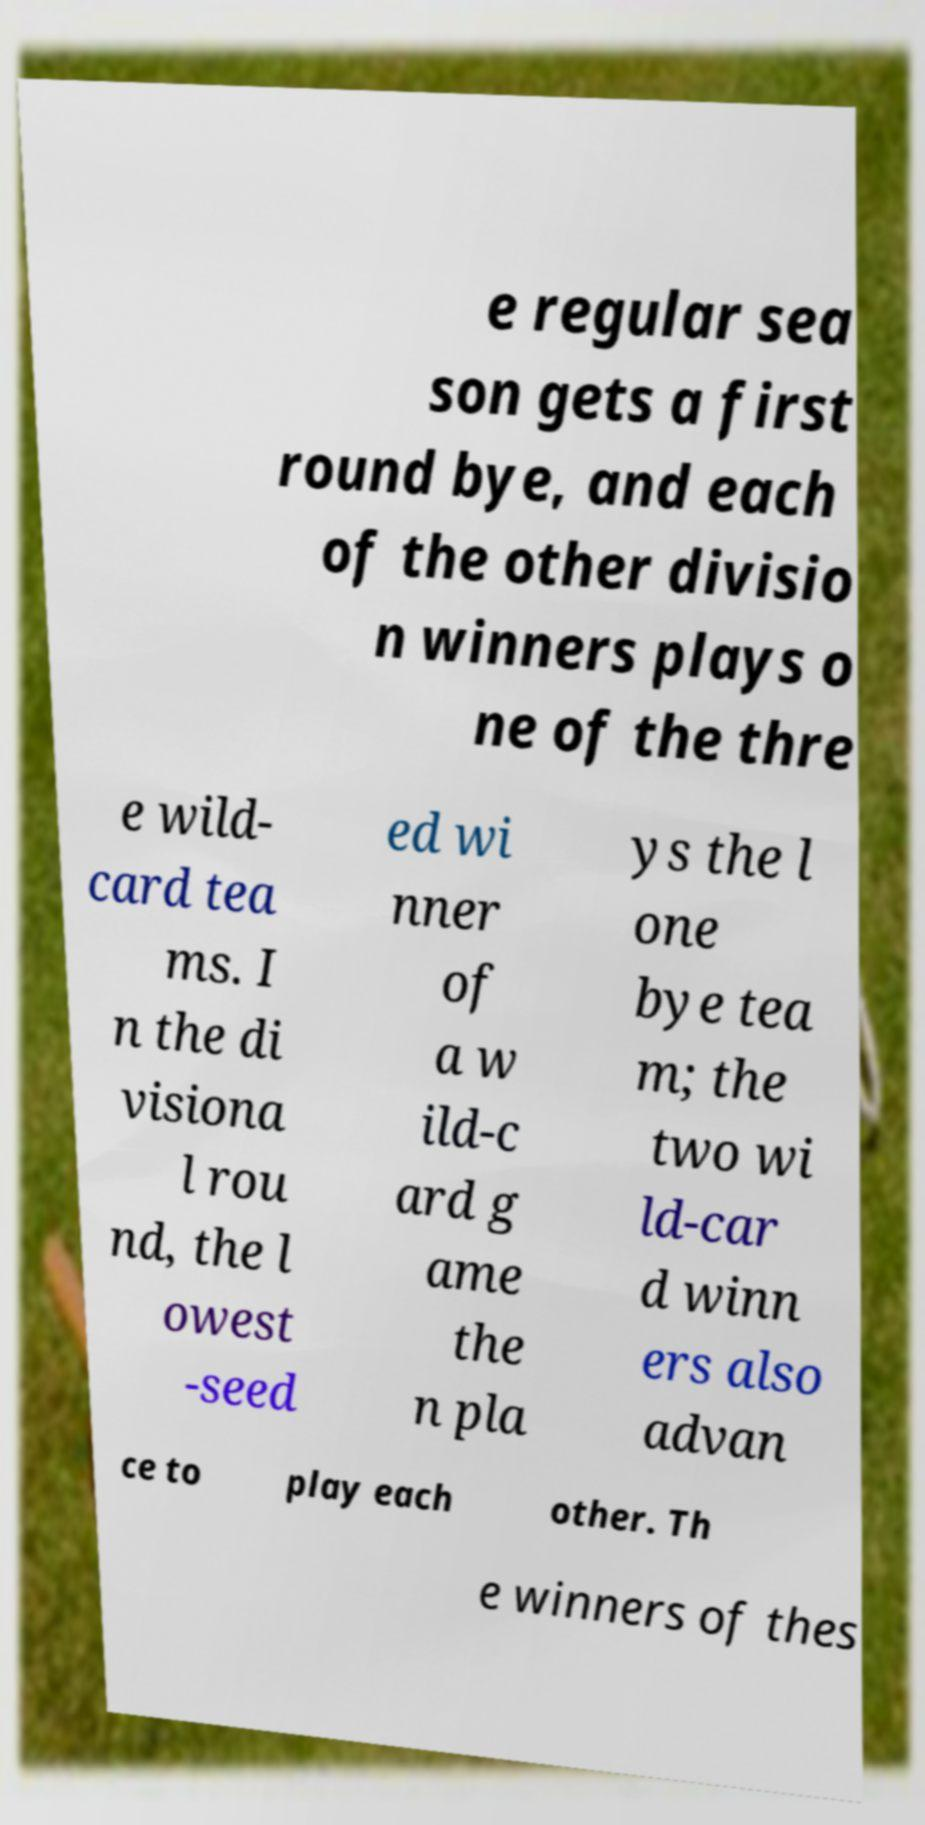There's text embedded in this image that I need extracted. Can you transcribe it verbatim? e regular sea son gets a first round bye, and each of the other divisio n winners plays o ne of the thre e wild- card tea ms. I n the di visiona l rou nd, the l owest -seed ed wi nner of a w ild-c ard g ame the n pla ys the l one bye tea m; the two wi ld-car d winn ers also advan ce to play each other. Th e winners of thes 